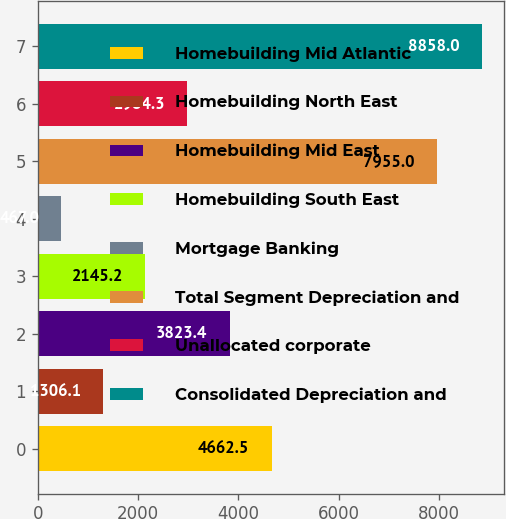<chart> <loc_0><loc_0><loc_500><loc_500><bar_chart><fcel>Homebuilding Mid Atlantic<fcel>Homebuilding North East<fcel>Homebuilding Mid East<fcel>Homebuilding South East<fcel>Mortgage Banking<fcel>Total Segment Depreciation and<fcel>Unallocated corporate<fcel>Consolidated Depreciation and<nl><fcel>4662.5<fcel>1306.1<fcel>3823.4<fcel>2145.2<fcel>467<fcel>7955<fcel>2984.3<fcel>8858<nl></chart> 